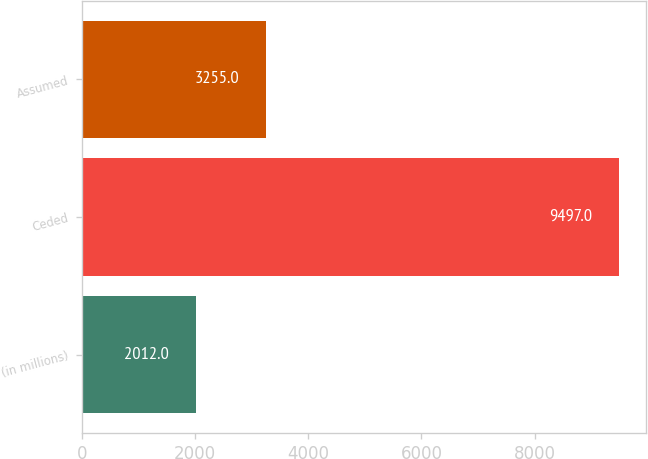Convert chart. <chart><loc_0><loc_0><loc_500><loc_500><bar_chart><fcel>(in millions)<fcel>Ceded<fcel>Assumed<nl><fcel>2012<fcel>9497<fcel>3255<nl></chart> 